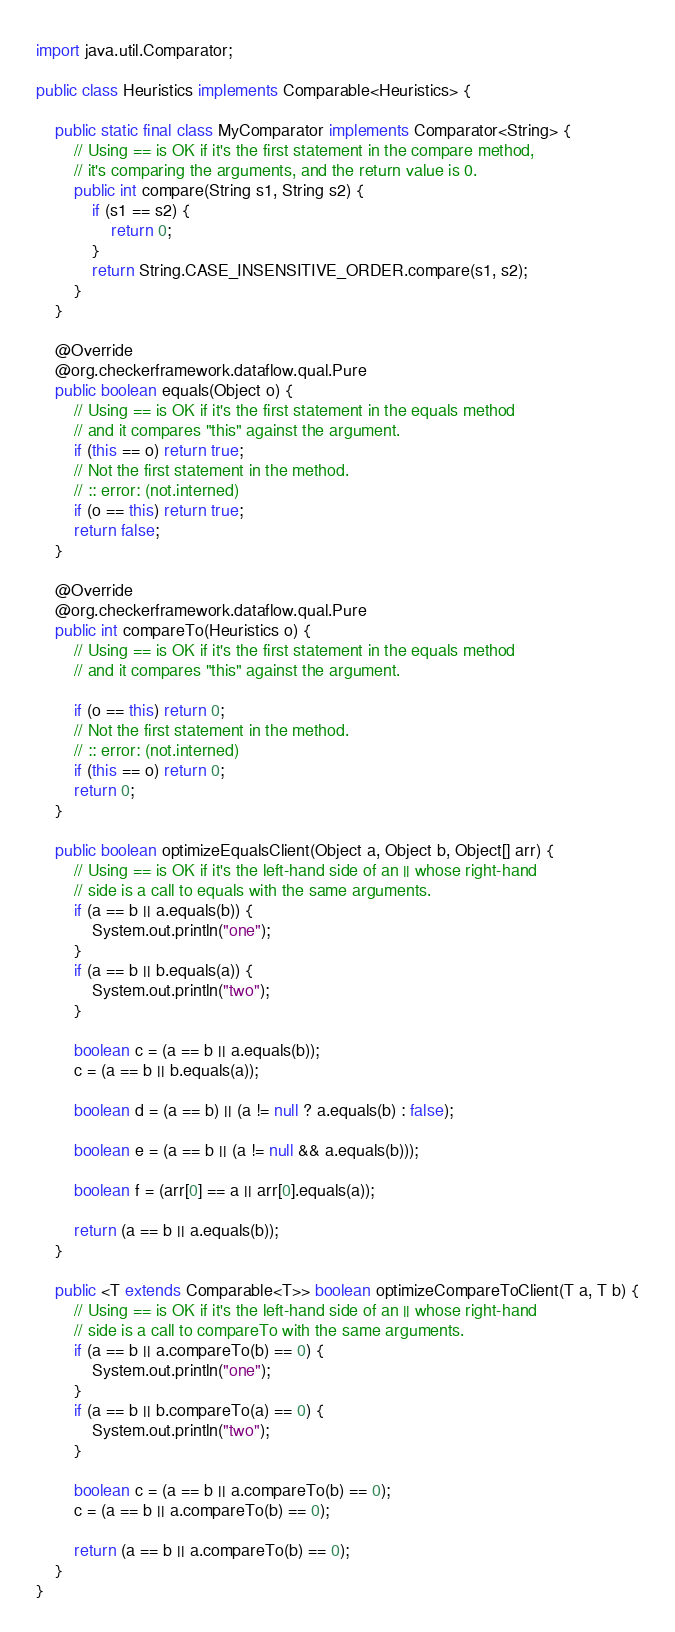Convert code to text. <code><loc_0><loc_0><loc_500><loc_500><_Java_>import java.util.Comparator;

public class Heuristics implements Comparable<Heuristics> {

    public static final class MyComparator implements Comparator<String> {
        // Using == is OK if it's the first statement in the compare method,
        // it's comparing the arguments, and the return value is 0.
        public int compare(String s1, String s2) {
            if (s1 == s2) {
                return 0;
            }
            return String.CASE_INSENSITIVE_ORDER.compare(s1, s2);
        }
    }

    @Override
    @org.checkerframework.dataflow.qual.Pure
    public boolean equals(Object o) {
        // Using == is OK if it's the first statement in the equals method
        // and it compares "this" against the argument.
        if (this == o) return true;
        // Not the first statement in the method.
        // :: error: (not.interned)
        if (o == this) return true;
        return false;
    }

    @Override
    @org.checkerframework.dataflow.qual.Pure
    public int compareTo(Heuristics o) {
        // Using == is OK if it's the first statement in the equals method
        // and it compares "this" against the argument.

        if (o == this) return 0;
        // Not the first statement in the method.
        // :: error: (not.interned)
        if (this == o) return 0;
        return 0;
    }

    public boolean optimizeEqualsClient(Object a, Object b, Object[] arr) {
        // Using == is OK if it's the left-hand side of an || whose right-hand
        // side is a call to equals with the same arguments.
        if (a == b || a.equals(b)) {
            System.out.println("one");
        }
        if (a == b || b.equals(a)) {
            System.out.println("two");
        }

        boolean c = (a == b || a.equals(b));
        c = (a == b || b.equals(a));

        boolean d = (a == b) || (a != null ? a.equals(b) : false);

        boolean e = (a == b || (a != null && a.equals(b)));

        boolean f = (arr[0] == a || arr[0].equals(a));

        return (a == b || a.equals(b));
    }

    public <T extends Comparable<T>> boolean optimizeCompareToClient(T a, T b) {
        // Using == is OK if it's the left-hand side of an || whose right-hand
        // side is a call to compareTo with the same arguments.
        if (a == b || a.compareTo(b) == 0) {
            System.out.println("one");
        }
        if (a == b || b.compareTo(a) == 0) {
            System.out.println("two");
        }

        boolean c = (a == b || a.compareTo(b) == 0);
        c = (a == b || a.compareTo(b) == 0);

        return (a == b || a.compareTo(b) == 0);
    }
}
</code> 